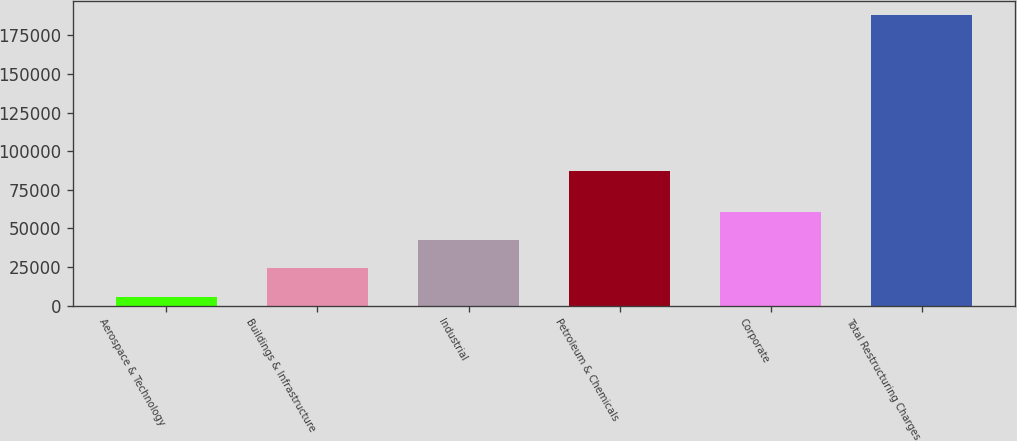Convert chart to OTSL. <chart><loc_0><loc_0><loc_500><loc_500><bar_chart><fcel>Aerospace & Technology<fcel>Buildings & Infrastructure<fcel>Industrial<fcel>Petroleum & Chemicals<fcel>Corporate<fcel>Total Restructuring Charges<nl><fcel>5835<fcel>24042.2<fcel>42249.4<fcel>87188<fcel>60456.6<fcel>187907<nl></chart> 